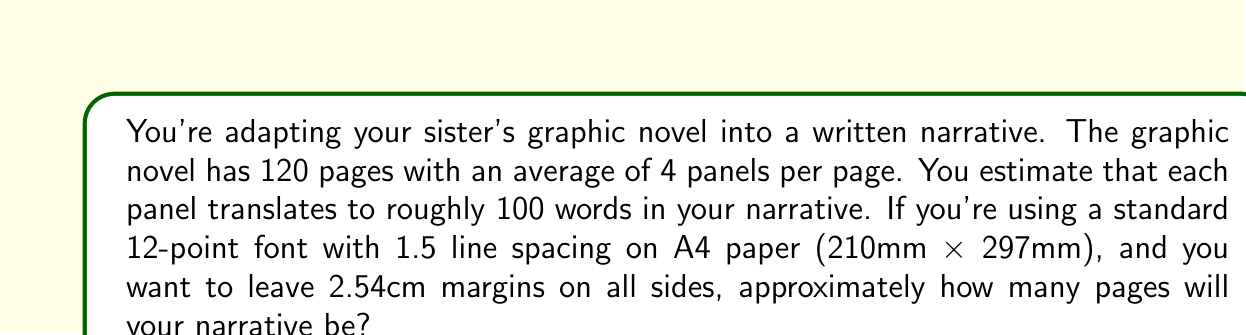Could you help me with this problem? Let's approach this step-by-step:

1. Calculate the total number of words:
   $$ \text{Total words} = \text{Pages} \times \text{Panels per page} \times \text{Words per panel} $$
   $$ \text{Total words} = 120 \times 4 \times 100 = 48,000 \text{ words} $$

2. Calculate the printable area on an A4 page:
   - A4 dimensions: 210mm x 297mm
   - Margins: 2.54cm = 25.4mm on all sides
   - Printable width: $210 - (2 \times 25.4) = 159.2\text{mm}$
   - Printable height: $297 - (2 \times 25.4) = 246.2\text{mm}$

3. Estimate the number of characters per line:
   - Assuming 12-point font, which is about 4.23mm tall
   - Character width is typically about 60% of height, so approximately 2.54mm
   $$ \text{Characters per line} \approx \frac{159.2\text{mm}}{2.54\text{mm}} \approx 63 \text{ characters} $$

4. Estimate the number of lines per page:
   - 1.5 line spacing means each line takes up $4.23\text{mm} \times 1.5 = 6.345\text{mm}$
   $$ \text{Lines per page} \approx \frac{246.2\text{mm}}{6.345\text{mm}} \approx 39 \text{ lines} $$

5. Calculate words per page:
   - Assume an average word length of 5 characters plus a space (6 characters total)
   $$ \text{Words per line} \approx \frac{63 \text{ characters}}{6 \text{ characters per word}} \approx 10.5 \text{ words} $$
   $$ \text{Words per page} = 10.5 \times 39 \approx 410 \text{ words} $$

6. Finally, calculate the total number of pages:
   $$ \text{Total pages} = \frac{\text{Total words}}{\text{Words per page}} = \frac{48,000}{410} \approx 117 \text{ pages} $$
Answer: Approximately 117 pages 